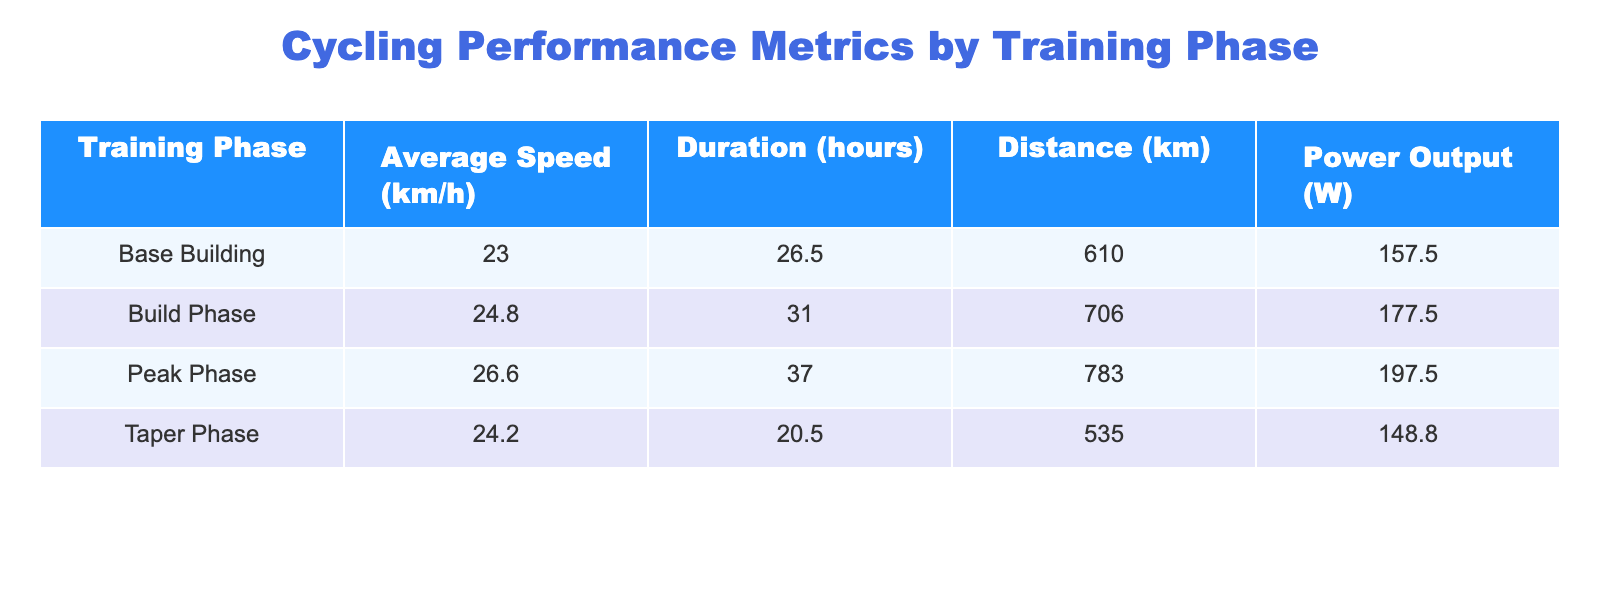What is the average speed during the Peak Phase? To find the average speed during the Peak Phase, I take the average speed values from the Peak Phase rows: 26.0, 26.5, 26.8, and 27.0 km/h. Summing these gives 106.3 km/h. Dividing by the number of weeks (4), I get 106.3/4 = 26.575, which rounds to 26.6 km/h.
Answer: 26.6 What is the total distance covered during the Build Phase? To calculate the total distance for the Build Phase, I sum the distance values from weeks 5 to 8: 168, 173, 180, and 185 km. Adding these gives 168 + 173 + 180 + 185 = 706 km.
Answer: 706 Was the average power output higher during the Base Building phase compared to the Taper phase? I need to compare the average power output of both phases. For the Base Building phase, the average power outputs are 150, 155, 160, and 165 W, which average to (150 + 155 + 160 + 165) / 4 = 157.5 W. For the Taper phase, the outputs are 160, 150, 145, and 140 W, averaging to (160 + 150 + 145 + 140) / 4 = 148.75 W. Since 157.5 is greater than 148.75, the statement is true.
Answer: Yes What was the longest training duration in hours of any training phase? I need to look for the maximum in the Duration column. The maximum values from all phases are: 6, 6.5, 7, 7, 7.5, 8, 8.5, 8.5, 9, 9.5, 10, 6, 5, 5, and 4.5 hours. The longest duration is 10 hours during the Peak Phase Week 12.
Answer: 10 How much greater was the average speed in the Taper phase compared to the Base Building phase? First, I need to find the averages: Base Building average speed is calculated as (22.5 + 23.0 + 23.2 + 23.5) / 4 = 23.3 km/h. Taper average speed is (25.0 + 24.5 + 24.0 + 23.5) / 4 = 24.3 km/h. The difference is 24.3 - 23.3 = 1 km/h.
Answer: 1 What is the total power output during the Peak Phase? To find the total power output during the Peak Phase, I sum the power outputs from weeks 9 to 12: 190, 195, 200, and 205 W. Adding these gives 190 + 195 + 200 + 205 = 790 W.
Answer: 790 Is there a week in the Build Phase where the average speed exceeded 25 km/h? The average speeds for the Build Phase weeks are 24.0, 24.5, 25.0, and 25.5 km/h. The only weeks where the speed exceeds 25 km/h are the last two weeks (weeks 7 and 8). Therefore, there are two instances of this happening.
Answer: Yes What was the total duration across all training phases? To find the total duration, I sum all durations in the table: 6 + 6.5 + 7 + 7 + 7.5 + 8 + 8.5 + 8.5 + 9 + 9.5 + 10 + 6 + 5 + 5 + 4.5 = 107 hours.
Answer: 107 